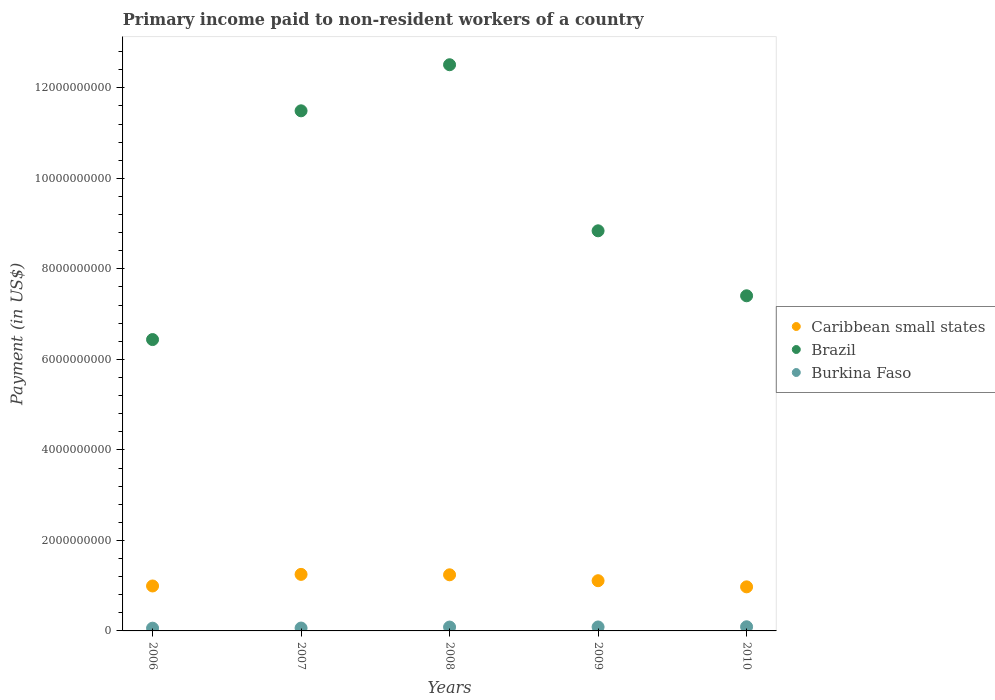What is the amount paid to workers in Burkina Faso in 2010?
Your answer should be compact. 9.17e+07. Across all years, what is the maximum amount paid to workers in Brazil?
Give a very brief answer. 1.25e+1. Across all years, what is the minimum amount paid to workers in Brazil?
Your answer should be very brief. 6.44e+09. What is the total amount paid to workers in Burkina Faso in the graph?
Offer a very short reply. 3.88e+08. What is the difference between the amount paid to workers in Brazil in 2006 and that in 2007?
Ensure brevity in your answer.  -5.05e+09. What is the difference between the amount paid to workers in Caribbean small states in 2006 and the amount paid to workers in Burkina Faso in 2008?
Offer a terse response. 9.08e+08. What is the average amount paid to workers in Brazil per year?
Make the answer very short. 9.34e+09. In the year 2008, what is the difference between the amount paid to workers in Burkina Faso and amount paid to workers in Brazil?
Provide a short and direct response. -1.24e+1. What is the ratio of the amount paid to workers in Caribbean small states in 2008 to that in 2010?
Your response must be concise. 1.27. Is the amount paid to workers in Caribbean small states in 2006 less than that in 2010?
Your answer should be very brief. No. What is the difference between the highest and the second highest amount paid to workers in Burkina Faso?
Offer a very short reply. 4.26e+06. What is the difference between the highest and the lowest amount paid to workers in Burkina Faso?
Give a very brief answer. 3.12e+07. In how many years, is the amount paid to workers in Burkina Faso greater than the average amount paid to workers in Burkina Faso taken over all years?
Provide a succinct answer. 3. How many years are there in the graph?
Provide a succinct answer. 5. Does the graph contain any zero values?
Your answer should be very brief. No. Does the graph contain grids?
Your response must be concise. No. Where does the legend appear in the graph?
Your response must be concise. Center right. How are the legend labels stacked?
Your answer should be compact. Vertical. What is the title of the graph?
Ensure brevity in your answer.  Primary income paid to non-resident workers of a country. What is the label or title of the X-axis?
Give a very brief answer. Years. What is the label or title of the Y-axis?
Provide a short and direct response. Payment (in US$). What is the Payment (in US$) in Caribbean small states in 2006?
Offer a terse response. 9.93e+08. What is the Payment (in US$) of Brazil in 2006?
Your answer should be compact. 6.44e+09. What is the Payment (in US$) of Burkina Faso in 2006?
Give a very brief answer. 6.05e+07. What is the Payment (in US$) in Caribbean small states in 2007?
Provide a short and direct response. 1.25e+09. What is the Payment (in US$) in Brazil in 2007?
Ensure brevity in your answer.  1.15e+1. What is the Payment (in US$) of Burkina Faso in 2007?
Your answer should be very brief. 6.34e+07. What is the Payment (in US$) in Caribbean small states in 2008?
Provide a succinct answer. 1.24e+09. What is the Payment (in US$) in Brazil in 2008?
Your answer should be compact. 1.25e+1. What is the Payment (in US$) of Burkina Faso in 2008?
Your answer should be compact. 8.53e+07. What is the Payment (in US$) of Caribbean small states in 2009?
Provide a short and direct response. 1.11e+09. What is the Payment (in US$) of Brazil in 2009?
Your answer should be compact. 8.84e+09. What is the Payment (in US$) in Burkina Faso in 2009?
Give a very brief answer. 8.74e+07. What is the Payment (in US$) of Caribbean small states in 2010?
Offer a very short reply. 9.74e+08. What is the Payment (in US$) in Brazil in 2010?
Your answer should be compact. 7.41e+09. What is the Payment (in US$) in Burkina Faso in 2010?
Provide a short and direct response. 9.17e+07. Across all years, what is the maximum Payment (in US$) in Caribbean small states?
Make the answer very short. 1.25e+09. Across all years, what is the maximum Payment (in US$) in Brazil?
Give a very brief answer. 1.25e+1. Across all years, what is the maximum Payment (in US$) of Burkina Faso?
Your response must be concise. 9.17e+07. Across all years, what is the minimum Payment (in US$) in Caribbean small states?
Offer a terse response. 9.74e+08. Across all years, what is the minimum Payment (in US$) of Brazil?
Make the answer very short. 6.44e+09. Across all years, what is the minimum Payment (in US$) in Burkina Faso?
Give a very brief answer. 6.05e+07. What is the total Payment (in US$) in Caribbean small states in the graph?
Make the answer very short. 5.57e+09. What is the total Payment (in US$) of Brazil in the graph?
Offer a terse response. 4.67e+1. What is the total Payment (in US$) of Burkina Faso in the graph?
Provide a short and direct response. 3.88e+08. What is the difference between the Payment (in US$) of Caribbean small states in 2006 and that in 2007?
Ensure brevity in your answer.  -2.56e+08. What is the difference between the Payment (in US$) in Brazil in 2006 and that in 2007?
Your response must be concise. -5.05e+09. What is the difference between the Payment (in US$) of Burkina Faso in 2006 and that in 2007?
Your answer should be compact. -2.89e+06. What is the difference between the Payment (in US$) in Caribbean small states in 2006 and that in 2008?
Provide a short and direct response. -2.47e+08. What is the difference between the Payment (in US$) in Brazil in 2006 and that in 2008?
Provide a short and direct response. -6.07e+09. What is the difference between the Payment (in US$) of Burkina Faso in 2006 and that in 2008?
Offer a very short reply. -2.48e+07. What is the difference between the Payment (in US$) of Caribbean small states in 2006 and that in 2009?
Your response must be concise. -1.16e+08. What is the difference between the Payment (in US$) of Brazil in 2006 and that in 2009?
Provide a short and direct response. -2.40e+09. What is the difference between the Payment (in US$) in Burkina Faso in 2006 and that in 2009?
Provide a succinct answer. -2.69e+07. What is the difference between the Payment (in US$) in Caribbean small states in 2006 and that in 2010?
Make the answer very short. 1.95e+07. What is the difference between the Payment (in US$) in Brazil in 2006 and that in 2010?
Your response must be concise. -9.67e+08. What is the difference between the Payment (in US$) in Burkina Faso in 2006 and that in 2010?
Give a very brief answer. -3.12e+07. What is the difference between the Payment (in US$) in Caribbean small states in 2007 and that in 2008?
Give a very brief answer. 9.21e+06. What is the difference between the Payment (in US$) in Brazil in 2007 and that in 2008?
Provide a succinct answer. -1.02e+09. What is the difference between the Payment (in US$) in Burkina Faso in 2007 and that in 2008?
Keep it short and to the point. -2.19e+07. What is the difference between the Payment (in US$) in Caribbean small states in 2007 and that in 2009?
Provide a succinct answer. 1.40e+08. What is the difference between the Payment (in US$) of Brazil in 2007 and that in 2009?
Give a very brief answer. 2.65e+09. What is the difference between the Payment (in US$) in Burkina Faso in 2007 and that in 2009?
Your response must be concise. -2.40e+07. What is the difference between the Payment (in US$) in Caribbean small states in 2007 and that in 2010?
Offer a terse response. 2.76e+08. What is the difference between the Payment (in US$) of Brazil in 2007 and that in 2010?
Make the answer very short. 4.09e+09. What is the difference between the Payment (in US$) in Burkina Faso in 2007 and that in 2010?
Keep it short and to the point. -2.83e+07. What is the difference between the Payment (in US$) of Caribbean small states in 2008 and that in 2009?
Ensure brevity in your answer.  1.31e+08. What is the difference between the Payment (in US$) of Brazil in 2008 and that in 2009?
Make the answer very short. 3.67e+09. What is the difference between the Payment (in US$) in Burkina Faso in 2008 and that in 2009?
Make the answer very short. -2.12e+06. What is the difference between the Payment (in US$) in Caribbean small states in 2008 and that in 2010?
Your answer should be compact. 2.66e+08. What is the difference between the Payment (in US$) in Brazil in 2008 and that in 2010?
Your answer should be compact. 5.11e+09. What is the difference between the Payment (in US$) of Burkina Faso in 2008 and that in 2010?
Give a very brief answer. -6.38e+06. What is the difference between the Payment (in US$) of Caribbean small states in 2009 and that in 2010?
Your response must be concise. 1.36e+08. What is the difference between the Payment (in US$) in Brazil in 2009 and that in 2010?
Offer a very short reply. 1.44e+09. What is the difference between the Payment (in US$) of Burkina Faso in 2009 and that in 2010?
Ensure brevity in your answer.  -4.26e+06. What is the difference between the Payment (in US$) of Caribbean small states in 2006 and the Payment (in US$) of Brazil in 2007?
Offer a terse response. -1.05e+1. What is the difference between the Payment (in US$) of Caribbean small states in 2006 and the Payment (in US$) of Burkina Faso in 2007?
Give a very brief answer. 9.30e+08. What is the difference between the Payment (in US$) of Brazil in 2006 and the Payment (in US$) of Burkina Faso in 2007?
Your response must be concise. 6.37e+09. What is the difference between the Payment (in US$) in Caribbean small states in 2006 and the Payment (in US$) in Brazil in 2008?
Offer a terse response. -1.15e+1. What is the difference between the Payment (in US$) in Caribbean small states in 2006 and the Payment (in US$) in Burkina Faso in 2008?
Offer a terse response. 9.08e+08. What is the difference between the Payment (in US$) of Brazil in 2006 and the Payment (in US$) of Burkina Faso in 2008?
Your response must be concise. 6.35e+09. What is the difference between the Payment (in US$) in Caribbean small states in 2006 and the Payment (in US$) in Brazil in 2009?
Offer a terse response. -7.85e+09. What is the difference between the Payment (in US$) in Caribbean small states in 2006 and the Payment (in US$) in Burkina Faso in 2009?
Offer a very short reply. 9.06e+08. What is the difference between the Payment (in US$) of Brazil in 2006 and the Payment (in US$) of Burkina Faso in 2009?
Your answer should be compact. 6.35e+09. What is the difference between the Payment (in US$) of Caribbean small states in 2006 and the Payment (in US$) of Brazil in 2010?
Offer a very short reply. -6.41e+09. What is the difference between the Payment (in US$) of Caribbean small states in 2006 and the Payment (in US$) of Burkina Faso in 2010?
Keep it short and to the point. 9.02e+08. What is the difference between the Payment (in US$) of Brazil in 2006 and the Payment (in US$) of Burkina Faso in 2010?
Make the answer very short. 6.35e+09. What is the difference between the Payment (in US$) of Caribbean small states in 2007 and the Payment (in US$) of Brazil in 2008?
Ensure brevity in your answer.  -1.13e+1. What is the difference between the Payment (in US$) in Caribbean small states in 2007 and the Payment (in US$) in Burkina Faso in 2008?
Make the answer very short. 1.16e+09. What is the difference between the Payment (in US$) in Brazil in 2007 and the Payment (in US$) in Burkina Faso in 2008?
Provide a succinct answer. 1.14e+1. What is the difference between the Payment (in US$) of Caribbean small states in 2007 and the Payment (in US$) of Brazil in 2009?
Give a very brief answer. -7.59e+09. What is the difference between the Payment (in US$) of Caribbean small states in 2007 and the Payment (in US$) of Burkina Faso in 2009?
Provide a succinct answer. 1.16e+09. What is the difference between the Payment (in US$) of Brazil in 2007 and the Payment (in US$) of Burkina Faso in 2009?
Offer a terse response. 1.14e+1. What is the difference between the Payment (in US$) of Caribbean small states in 2007 and the Payment (in US$) of Brazil in 2010?
Provide a succinct answer. -6.16e+09. What is the difference between the Payment (in US$) in Caribbean small states in 2007 and the Payment (in US$) in Burkina Faso in 2010?
Make the answer very short. 1.16e+09. What is the difference between the Payment (in US$) in Brazil in 2007 and the Payment (in US$) in Burkina Faso in 2010?
Ensure brevity in your answer.  1.14e+1. What is the difference between the Payment (in US$) in Caribbean small states in 2008 and the Payment (in US$) in Brazil in 2009?
Keep it short and to the point. -7.60e+09. What is the difference between the Payment (in US$) of Caribbean small states in 2008 and the Payment (in US$) of Burkina Faso in 2009?
Ensure brevity in your answer.  1.15e+09. What is the difference between the Payment (in US$) of Brazil in 2008 and the Payment (in US$) of Burkina Faso in 2009?
Provide a short and direct response. 1.24e+1. What is the difference between the Payment (in US$) in Caribbean small states in 2008 and the Payment (in US$) in Brazil in 2010?
Your response must be concise. -6.17e+09. What is the difference between the Payment (in US$) in Caribbean small states in 2008 and the Payment (in US$) in Burkina Faso in 2010?
Offer a terse response. 1.15e+09. What is the difference between the Payment (in US$) in Brazil in 2008 and the Payment (in US$) in Burkina Faso in 2010?
Your response must be concise. 1.24e+1. What is the difference between the Payment (in US$) of Caribbean small states in 2009 and the Payment (in US$) of Brazil in 2010?
Make the answer very short. -6.30e+09. What is the difference between the Payment (in US$) of Caribbean small states in 2009 and the Payment (in US$) of Burkina Faso in 2010?
Provide a short and direct response. 1.02e+09. What is the difference between the Payment (in US$) in Brazil in 2009 and the Payment (in US$) in Burkina Faso in 2010?
Offer a very short reply. 8.75e+09. What is the average Payment (in US$) in Caribbean small states per year?
Your answer should be very brief. 1.11e+09. What is the average Payment (in US$) of Brazil per year?
Offer a terse response. 9.34e+09. What is the average Payment (in US$) of Burkina Faso per year?
Your response must be concise. 7.76e+07. In the year 2006, what is the difference between the Payment (in US$) in Caribbean small states and Payment (in US$) in Brazil?
Provide a succinct answer. -5.44e+09. In the year 2006, what is the difference between the Payment (in US$) of Caribbean small states and Payment (in US$) of Burkina Faso?
Provide a short and direct response. 9.33e+08. In the year 2006, what is the difference between the Payment (in US$) in Brazil and Payment (in US$) in Burkina Faso?
Your answer should be compact. 6.38e+09. In the year 2007, what is the difference between the Payment (in US$) in Caribbean small states and Payment (in US$) in Brazil?
Your answer should be very brief. -1.02e+1. In the year 2007, what is the difference between the Payment (in US$) in Caribbean small states and Payment (in US$) in Burkina Faso?
Offer a terse response. 1.19e+09. In the year 2007, what is the difference between the Payment (in US$) of Brazil and Payment (in US$) of Burkina Faso?
Offer a very short reply. 1.14e+1. In the year 2008, what is the difference between the Payment (in US$) in Caribbean small states and Payment (in US$) in Brazil?
Keep it short and to the point. -1.13e+1. In the year 2008, what is the difference between the Payment (in US$) of Caribbean small states and Payment (in US$) of Burkina Faso?
Provide a succinct answer. 1.15e+09. In the year 2008, what is the difference between the Payment (in US$) of Brazil and Payment (in US$) of Burkina Faso?
Your response must be concise. 1.24e+1. In the year 2009, what is the difference between the Payment (in US$) of Caribbean small states and Payment (in US$) of Brazil?
Provide a short and direct response. -7.73e+09. In the year 2009, what is the difference between the Payment (in US$) in Caribbean small states and Payment (in US$) in Burkina Faso?
Provide a short and direct response. 1.02e+09. In the year 2009, what is the difference between the Payment (in US$) in Brazil and Payment (in US$) in Burkina Faso?
Provide a short and direct response. 8.75e+09. In the year 2010, what is the difference between the Payment (in US$) in Caribbean small states and Payment (in US$) in Brazil?
Keep it short and to the point. -6.43e+09. In the year 2010, what is the difference between the Payment (in US$) of Caribbean small states and Payment (in US$) of Burkina Faso?
Ensure brevity in your answer.  8.82e+08. In the year 2010, what is the difference between the Payment (in US$) in Brazil and Payment (in US$) in Burkina Faso?
Keep it short and to the point. 7.31e+09. What is the ratio of the Payment (in US$) in Caribbean small states in 2006 to that in 2007?
Make the answer very short. 0.8. What is the ratio of the Payment (in US$) in Brazil in 2006 to that in 2007?
Give a very brief answer. 0.56. What is the ratio of the Payment (in US$) of Burkina Faso in 2006 to that in 2007?
Provide a succinct answer. 0.95. What is the ratio of the Payment (in US$) in Caribbean small states in 2006 to that in 2008?
Give a very brief answer. 0.8. What is the ratio of the Payment (in US$) in Brazil in 2006 to that in 2008?
Provide a succinct answer. 0.51. What is the ratio of the Payment (in US$) of Burkina Faso in 2006 to that in 2008?
Ensure brevity in your answer.  0.71. What is the ratio of the Payment (in US$) in Caribbean small states in 2006 to that in 2009?
Ensure brevity in your answer.  0.9. What is the ratio of the Payment (in US$) of Brazil in 2006 to that in 2009?
Make the answer very short. 0.73. What is the ratio of the Payment (in US$) in Burkina Faso in 2006 to that in 2009?
Offer a very short reply. 0.69. What is the ratio of the Payment (in US$) of Caribbean small states in 2006 to that in 2010?
Offer a terse response. 1.02. What is the ratio of the Payment (in US$) of Brazil in 2006 to that in 2010?
Provide a short and direct response. 0.87. What is the ratio of the Payment (in US$) of Burkina Faso in 2006 to that in 2010?
Offer a very short reply. 0.66. What is the ratio of the Payment (in US$) in Caribbean small states in 2007 to that in 2008?
Ensure brevity in your answer.  1.01. What is the ratio of the Payment (in US$) in Brazil in 2007 to that in 2008?
Ensure brevity in your answer.  0.92. What is the ratio of the Payment (in US$) of Burkina Faso in 2007 to that in 2008?
Ensure brevity in your answer.  0.74. What is the ratio of the Payment (in US$) of Caribbean small states in 2007 to that in 2009?
Your answer should be compact. 1.13. What is the ratio of the Payment (in US$) in Brazil in 2007 to that in 2009?
Make the answer very short. 1.3. What is the ratio of the Payment (in US$) in Burkina Faso in 2007 to that in 2009?
Offer a terse response. 0.72. What is the ratio of the Payment (in US$) in Caribbean small states in 2007 to that in 2010?
Keep it short and to the point. 1.28. What is the ratio of the Payment (in US$) in Brazil in 2007 to that in 2010?
Make the answer very short. 1.55. What is the ratio of the Payment (in US$) of Burkina Faso in 2007 to that in 2010?
Provide a short and direct response. 0.69. What is the ratio of the Payment (in US$) of Caribbean small states in 2008 to that in 2009?
Keep it short and to the point. 1.12. What is the ratio of the Payment (in US$) in Brazil in 2008 to that in 2009?
Your response must be concise. 1.42. What is the ratio of the Payment (in US$) of Burkina Faso in 2008 to that in 2009?
Make the answer very short. 0.98. What is the ratio of the Payment (in US$) in Caribbean small states in 2008 to that in 2010?
Make the answer very short. 1.27. What is the ratio of the Payment (in US$) in Brazil in 2008 to that in 2010?
Offer a very short reply. 1.69. What is the ratio of the Payment (in US$) in Burkina Faso in 2008 to that in 2010?
Your answer should be very brief. 0.93. What is the ratio of the Payment (in US$) in Caribbean small states in 2009 to that in 2010?
Your response must be concise. 1.14. What is the ratio of the Payment (in US$) of Brazil in 2009 to that in 2010?
Give a very brief answer. 1.19. What is the ratio of the Payment (in US$) of Burkina Faso in 2009 to that in 2010?
Your answer should be compact. 0.95. What is the difference between the highest and the second highest Payment (in US$) of Caribbean small states?
Give a very brief answer. 9.21e+06. What is the difference between the highest and the second highest Payment (in US$) in Brazil?
Ensure brevity in your answer.  1.02e+09. What is the difference between the highest and the second highest Payment (in US$) of Burkina Faso?
Your answer should be compact. 4.26e+06. What is the difference between the highest and the lowest Payment (in US$) in Caribbean small states?
Give a very brief answer. 2.76e+08. What is the difference between the highest and the lowest Payment (in US$) in Brazil?
Give a very brief answer. 6.07e+09. What is the difference between the highest and the lowest Payment (in US$) in Burkina Faso?
Make the answer very short. 3.12e+07. 